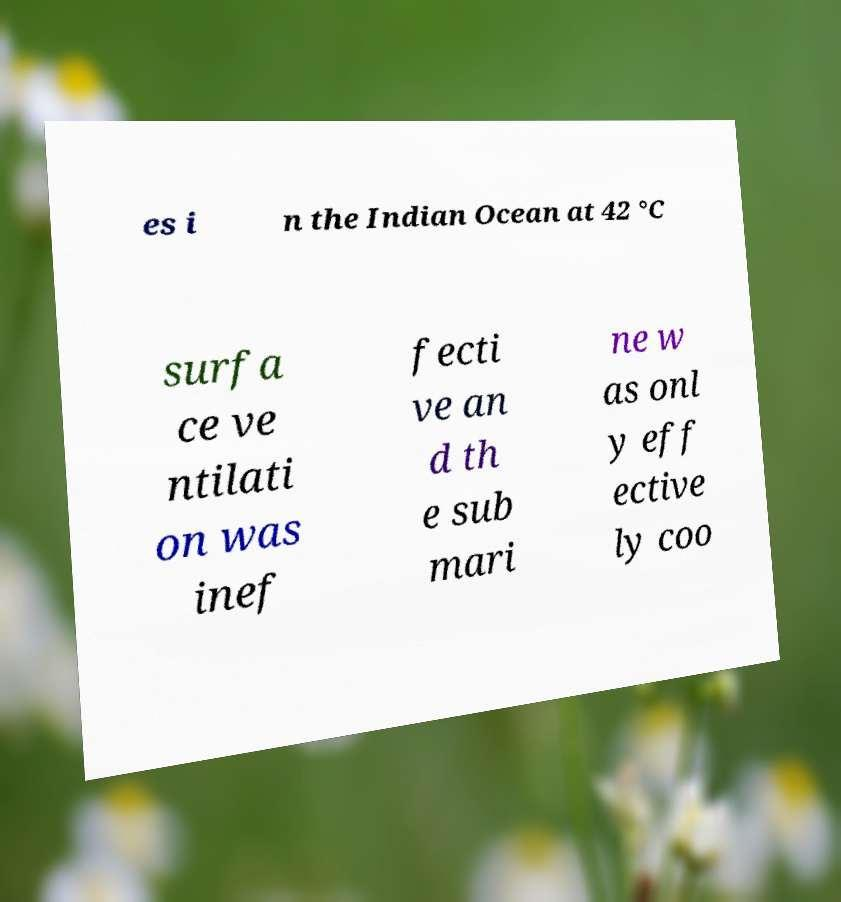For documentation purposes, I need the text within this image transcribed. Could you provide that? es i n the Indian Ocean at 42 °C surfa ce ve ntilati on was inef fecti ve an d th e sub mari ne w as onl y eff ective ly coo 